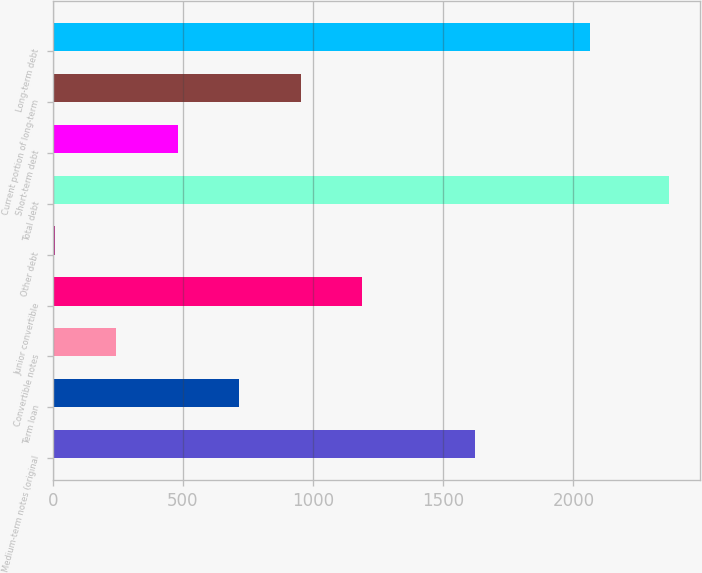<chart> <loc_0><loc_0><loc_500><loc_500><bar_chart><fcel>Medium-term notes (original<fcel>Term loan<fcel>Convertible notes<fcel>Junior convertible<fcel>Other debt<fcel>Total debt<fcel>Short-term debt<fcel>Current portion of long-term<fcel>Long-term debt<nl><fcel>1623<fcel>716.06<fcel>243.82<fcel>1188.3<fcel>7.7<fcel>2368.9<fcel>479.94<fcel>952.18<fcel>2063.9<nl></chart> 